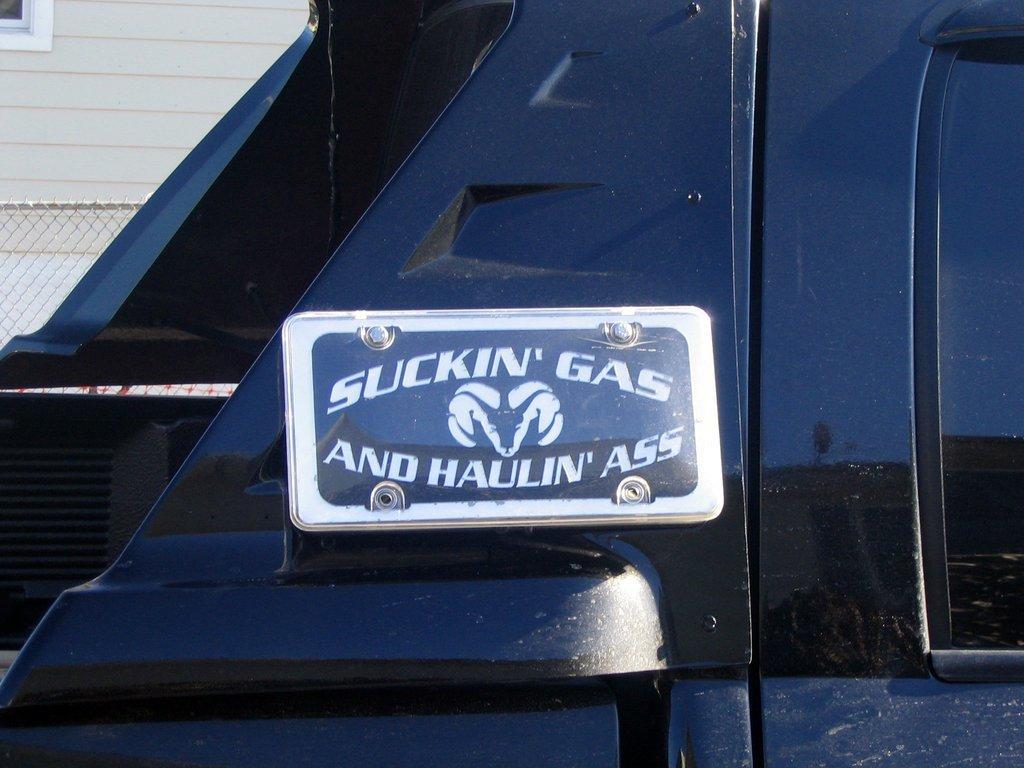How would you summarize this image in a sentence or two? The picture might be of a vehicle. In the middle there is a board. On the left we can see fencing, wall and window. 